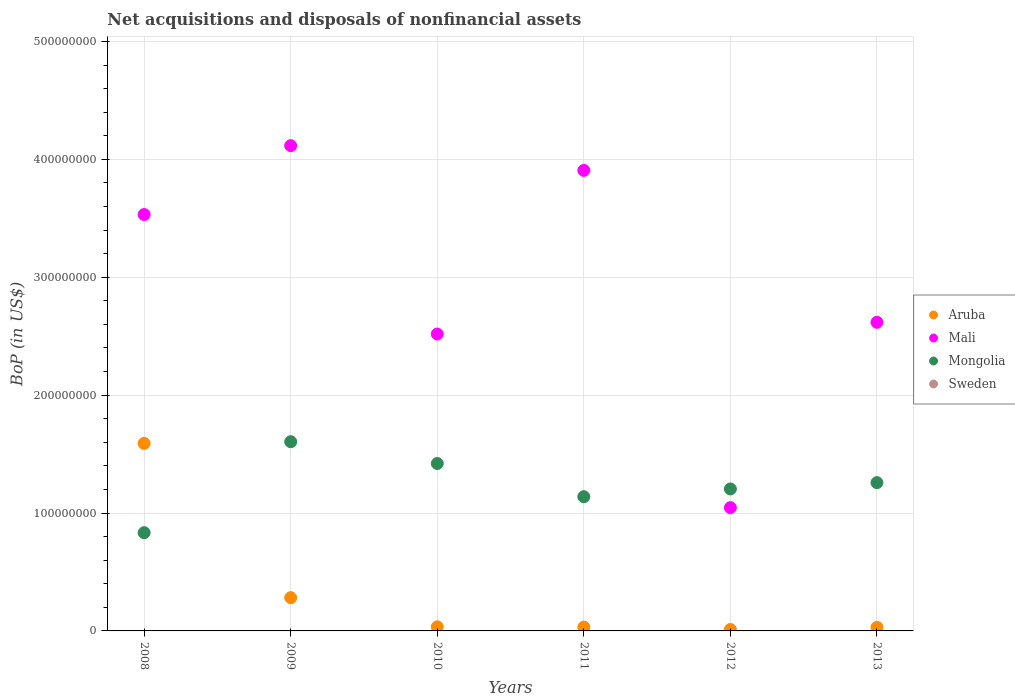Is the number of dotlines equal to the number of legend labels?
Offer a terse response. No. What is the Balance of Payments in Mongolia in 2011?
Provide a succinct answer. 1.14e+08. Across all years, what is the maximum Balance of Payments in Mali?
Your answer should be very brief. 4.12e+08. Across all years, what is the minimum Balance of Payments in Sweden?
Keep it short and to the point. 0. What is the total Balance of Payments in Mongolia in the graph?
Provide a short and direct response. 7.46e+08. What is the difference between the Balance of Payments in Mali in 2009 and that in 2010?
Offer a terse response. 1.60e+08. What is the difference between the Balance of Payments in Mongolia in 2013 and the Balance of Payments in Sweden in 2012?
Provide a short and direct response. 1.26e+08. What is the average Balance of Payments in Mongolia per year?
Give a very brief answer. 1.24e+08. In the year 2012, what is the difference between the Balance of Payments in Mongolia and Balance of Payments in Mali?
Offer a very short reply. 1.59e+07. What is the ratio of the Balance of Payments in Mongolia in 2008 to that in 2013?
Your answer should be very brief. 0.66. Is the Balance of Payments in Mongolia in 2009 less than that in 2012?
Your response must be concise. No. Is the difference between the Balance of Payments in Mongolia in 2010 and 2012 greater than the difference between the Balance of Payments in Mali in 2010 and 2012?
Keep it short and to the point. No. What is the difference between the highest and the second highest Balance of Payments in Mongolia?
Your response must be concise. 1.85e+07. What is the difference between the highest and the lowest Balance of Payments in Mongolia?
Your answer should be very brief. 7.72e+07. In how many years, is the Balance of Payments in Mongolia greater than the average Balance of Payments in Mongolia taken over all years?
Your answer should be compact. 3. Is the Balance of Payments in Mali strictly less than the Balance of Payments in Mongolia over the years?
Keep it short and to the point. No. What is the difference between two consecutive major ticks on the Y-axis?
Keep it short and to the point. 1.00e+08. Does the graph contain any zero values?
Offer a very short reply. Yes. Where does the legend appear in the graph?
Your answer should be compact. Center right. What is the title of the graph?
Give a very brief answer. Net acquisitions and disposals of nonfinancial assets. What is the label or title of the Y-axis?
Your answer should be compact. BoP (in US$). What is the BoP (in US$) of Aruba in 2008?
Provide a short and direct response. 1.59e+08. What is the BoP (in US$) of Mali in 2008?
Ensure brevity in your answer.  3.53e+08. What is the BoP (in US$) in Mongolia in 2008?
Your response must be concise. 8.33e+07. What is the BoP (in US$) in Sweden in 2008?
Make the answer very short. 0. What is the BoP (in US$) in Aruba in 2009?
Offer a terse response. 2.82e+07. What is the BoP (in US$) of Mali in 2009?
Your answer should be compact. 4.12e+08. What is the BoP (in US$) of Mongolia in 2009?
Keep it short and to the point. 1.60e+08. What is the BoP (in US$) of Aruba in 2010?
Give a very brief answer. 3.52e+06. What is the BoP (in US$) of Mali in 2010?
Your response must be concise. 2.52e+08. What is the BoP (in US$) in Mongolia in 2010?
Make the answer very short. 1.42e+08. What is the BoP (in US$) of Sweden in 2010?
Your answer should be very brief. 0. What is the BoP (in US$) of Aruba in 2011?
Offer a very short reply. 3.24e+06. What is the BoP (in US$) in Mali in 2011?
Make the answer very short. 3.91e+08. What is the BoP (in US$) in Mongolia in 2011?
Provide a short and direct response. 1.14e+08. What is the BoP (in US$) in Aruba in 2012?
Your answer should be very brief. 1.23e+06. What is the BoP (in US$) of Mali in 2012?
Offer a very short reply. 1.05e+08. What is the BoP (in US$) in Mongolia in 2012?
Offer a terse response. 1.20e+08. What is the BoP (in US$) of Sweden in 2012?
Offer a terse response. 0. What is the BoP (in US$) in Aruba in 2013?
Your response must be concise. 3.02e+06. What is the BoP (in US$) of Mali in 2013?
Ensure brevity in your answer.  2.62e+08. What is the BoP (in US$) in Mongolia in 2013?
Keep it short and to the point. 1.26e+08. Across all years, what is the maximum BoP (in US$) of Aruba?
Your answer should be compact. 1.59e+08. Across all years, what is the maximum BoP (in US$) of Mali?
Your answer should be compact. 4.12e+08. Across all years, what is the maximum BoP (in US$) of Mongolia?
Offer a terse response. 1.60e+08. Across all years, what is the minimum BoP (in US$) in Aruba?
Give a very brief answer. 1.23e+06. Across all years, what is the minimum BoP (in US$) of Mali?
Your answer should be very brief. 1.05e+08. Across all years, what is the minimum BoP (in US$) in Mongolia?
Provide a short and direct response. 8.33e+07. What is the total BoP (in US$) in Aruba in the graph?
Your response must be concise. 1.98e+08. What is the total BoP (in US$) of Mali in the graph?
Your answer should be very brief. 1.77e+09. What is the total BoP (in US$) in Mongolia in the graph?
Offer a very short reply. 7.46e+08. What is the difference between the BoP (in US$) in Aruba in 2008 and that in 2009?
Keep it short and to the point. 1.31e+08. What is the difference between the BoP (in US$) of Mali in 2008 and that in 2009?
Your answer should be very brief. -5.84e+07. What is the difference between the BoP (in US$) in Mongolia in 2008 and that in 2009?
Provide a succinct answer. -7.72e+07. What is the difference between the BoP (in US$) of Aruba in 2008 and that in 2010?
Offer a very short reply. 1.56e+08. What is the difference between the BoP (in US$) in Mali in 2008 and that in 2010?
Your answer should be compact. 1.01e+08. What is the difference between the BoP (in US$) of Mongolia in 2008 and that in 2010?
Provide a short and direct response. -5.87e+07. What is the difference between the BoP (in US$) in Aruba in 2008 and that in 2011?
Keep it short and to the point. 1.56e+08. What is the difference between the BoP (in US$) of Mali in 2008 and that in 2011?
Offer a terse response. -3.74e+07. What is the difference between the BoP (in US$) in Mongolia in 2008 and that in 2011?
Provide a short and direct response. -3.05e+07. What is the difference between the BoP (in US$) in Aruba in 2008 and that in 2012?
Provide a succinct answer. 1.58e+08. What is the difference between the BoP (in US$) in Mali in 2008 and that in 2012?
Provide a short and direct response. 2.49e+08. What is the difference between the BoP (in US$) in Mongolia in 2008 and that in 2012?
Make the answer very short. -3.71e+07. What is the difference between the BoP (in US$) of Aruba in 2008 and that in 2013?
Your response must be concise. 1.56e+08. What is the difference between the BoP (in US$) of Mali in 2008 and that in 2013?
Provide a succinct answer. 9.14e+07. What is the difference between the BoP (in US$) of Mongolia in 2008 and that in 2013?
Ensure brevity in your answer.  -4.25e+07. What is the difference between the BoP (in US$) of Aruba in 2009 and that in 2010?
Provide a succinct answer. 2.47e+07. What is the difference between the BoP (in US$) in Mali in 2009 and that in 2010?
Keep it short and to the point. 1.60e+08. What is the difference between the BoP (in US$) of Mongolia in 2009 and that in 2010?
Provide a succinct answer. 1.85e+07. What is the difference between the BoP (in US$) in Aruba in 2009 and that in 2011?
Your answer should be very brief. 2.50e+07. What is the difference between the BoP (in US$) in Mali in 2009 and that in 2011?
Offer a terse response. 2.10e+07. What is the difference between the BoP (in US$) of Mongolia in 2009 and that in 2011?
Offer a terse response. 4.66e+07. What is the difference between the BoP (in US$) in Aruba in 2009 and that in 2012?
Keep it short and to the point. 2.70e+07. What is the difference between the BoP (in US$) of Mali in 2009 and that in 2012?
Offer a terse response. 3.07e+08. What is the difference between the BoP (in US$) in Mongolia in 2009 and that in 2012?
Your answer should be compact. 4.01e+07. What is the difference between the BoP (in US$) in Aruba in 2009 and that in 2013?
Your answer should be very brief. 2.52e+07. What is the difference between the BoP (in US$) of Mali in 2009 and that in 2013?
Make the answer very short. 1.50e+08. What is the difference between the BoP (in US$) of Mongolia in 2009 and that in 2013?
Offer a very short reply. 3.47e+07. What is the difference between the BoP (in US$) in Aruba in 2010 and that in 2011?
Your answer should be compact. 2.79e+05. What is the difference between the BoP (in US$) in Mali in 2010 and that in 2011?
Ensure brevity in your answer.  -1.39e+08. What is the difference between the BoP (in US$) in Mongolia in 2010 and that in 2011?
Your answer should be compact. 2.81e+07. What is the difference between the BoP (in US$) of Aruba in 2010 and that in 2012?
Offer a terse response. 2.29e+06. What is the difference between the BoP (in US$) in Mali in 2010 and that in 2012?
Offer a terse response. 1.47e+08. What is the difference between the BoP (in US$) in Mongolia in 2010 and that in 2012?
Provide a succinct answer. 2.16e+07. What is the difference between the BoP (in US$) in Aruba in 2010 and that in 2013?
Provide a succinct answer. 5.03e+05. What is the difference between the BoP (in US$) in Mali in 2010 and that in 2013?
Provide a short and direct response. -9.95e+06. What is the difference between the BoP (in US$) in Mongolia in 2010 and that in 2013?
Make the answer very short. 1.62e+07. What is the difference between the BoP (in US$) of Aruba in 2011 and that in 2012?
Provide a succinct answer. 2.01e+06. What is the difference between the BoP (in US$) in Mali in 2011 and that in 2012?
Provide a short and direct response. 2.86e+08. What is the difference between the BoP (in US$) in Mongolia in 2011 and that in 2012?
Offer a terse response. -6.56e+06. What is the difference between the BoP (in US$) in Aruba in 2011 and that in 2013?
Your response must be concise. 2.23e+05. What is the difference between the BoP (in US$) in Mali in 2011 and that in 2013?
Keep it short and to the point. 1.29e+08. What is the difference between the BoP (in US$) in Mongolia in 2011 and that in 2013?
Provide a short and direct response. -1.19e+07. What is the difference between the BoP (in US$) of Aruba in 2012 and that in 2013?
Your answer should be very brief. -1.79e+06. What is the difference between the BoP (in US$) of Mali in 2012 and that in 2013?
Make the answer very short. -1.57e+08. What is the difference between the BoP (in US$) of Mongolia in 2012 and that in 2013?
Keep it short and to the point. -5.36e+06. What is the difference between the BoP (in US$) of Aruba in 2008 and the BoP (in US$) of Mali in 2009?
Your response must be concise. -2.53e+08. What is the difference between the BoP (in US$) in Aruba in 2008 and the BoP (in US$) in Mongolia in 2009?
Make the answer very short. -1.45e+06. What is the difference between the BoP (in US$) of Mali in 2008 and the BoP (in US$) of Mongolia in 2009?
Your answer should be very brief. 1.93e+08. What is the difference between the BoP (in US$) in Aruba in 2008 and the BoP (in US$) in Mali in 2010?
Your response must be concise. -9.28e+07. What is the difference between the BoP (in US$) in Aruba in 2008 and the BoP (in US$) in Mongolia in 2010?
Offer a terse response. 1.70e+07. What is the difference between the BoP (in US$) in Mali in 2008 and the BoP (in US$) in Mongolia in 2010?
Make the answer very short. 2.11e+08. What is the difference between the BoP (in US$) of Aruba in 2008 and the BoP (in US$) of Mali in 2011?
Your answer should be very brief. -2.32e+08. What is the difference between the BoP (in US$) of Aruba in 2008 and the BoP (in US$) of Mongolia in 2011?
Offer a terse response. 4.52e+07. What is the difference between the BoP (in US$) in Mali in 2008 and the BoP (in US$) in Mongolia in 2011?
Keep it short and to the point. 2.39e+08. What is the difference between the BoP (in US$) of Aruba in 2008 and the BoP (in US$) of Mali in 2012?
Keep it short and to the point. 5.45e+07. What is the difference between the BoP (in US$) in Aruba in 2008 and the BoP (in US$) in Mongolia in 2012?
Ensure brevity in your answer.  3.86e+07. What is the difference between the BoP (in US$) in Mali in 2008 and the BoP (in US$) in Mongolia in 2012?
Your answer should be compact. 2.33e+08. What is the difference between the BoP (in US$) in Aruba in 2008 and the BoP (in US$) in Mali in 2013?
Your answer should be very brief. -1.03e+08. What is the difference between the BoP (in US$) in Aruba in 2008 and the BoP (in US$) in Mongolia in 2013?
Offer a terse response. 3.33e+07. What is the difference between the BoP (in US$) of Mali in 2008 and the BoP (in US$) of Mongolia in 2013?
Make the answer very short. 2.27e+08. What is the difference between the BoP (in US$) of Aruba in 2009 and the BoP (in US$) of Mali in 2010?
Provide a short and direct response. -2.24e+08. What is the difference between the BoP (in US$) in Aruba in 2009 and the BoP (in US$) in Mongolia in 2010?
Make the answer very short. -1.14e+08. What is the difference between the BoP (in US$) in Mali in 2009 and the BoP (in US$) in Mongolia in 2010?
Give a very brief answer. 2.70e+08. What is the difference between the BoP (in US$) in Aruba in 2009 and the BoP (in US$) in Mali in 2011?
Your response must be concise. -3.62e+08. What is the difference between the BoP (in US$) of Aruba in 2009 and the BoP (in US$) of Mongolia in 2011?
Offer a very short reply. -8.57e+07. What is the difference between the BoP (in US$) of Mali in 2009 and the BoP (in US$) of Mongolia in 2011?
Your response must be concise. 2.98e+08. What is the difference between the BoP (in US$) of Aruba in 2009 and the BoP (in US$) of Mali in 2012?
Make the answer very short. -7.64e+07. What is the difference between the BoP (in US$) in Aruba in 2009 and the BoP (in US$) in Mongolia in 2012?
Your answer should be compact. -9.22e+07. What is the difference between the BoP (in US$) in Mali in 2009 and the BoP (in US$) in Mongolia in 2012?
Offer a very short reply. 2.91e+08. What is the difference between the BoP (in US$) of Aruba in 2009 and the BoP (in US$) of Mali in 2013?
Make the answer very short. -2.34e+08. What is the difference between the BoP (in US$) in Aruba in 2009 and the BoP (in US$) in Mongolia in 2013?
Ensure brevity in your answer.  -9.76e+07. What is the difference between the BoP (in US$) in Mali in 2009 and the BoP (in US$) in Mongolia in 2013?
Your response must be concise. 2.86e+08. What is the difference between the BoP (in US$) of Aruba in 2010 and the BoP (in US$) of Mali in 2011?
Your response must be concise. -3.87e+08. What is the difference between the BoP (in US$) in Aruba in 2010 and the BoP (in US$) in Mongolia in 2011?
Your answer should be compact. -1.10e+08. What is the difference between the BoP (in US$) of Mali in 2010 and the BoP (in US$) of Mongolia in 2011?
Give a very brief answer. 1.38e+08. What is the difference between the BoP (in US$) of Aruba in 2010 and the BoP (in US$) of Mali in 2012?
Make the answer very short. -1.01e+08. What is the difference between the BoP (in US$) of Aruba in 2010 and the BoP (in US$) of Mongolia in 2012?
Offer a very short reply. -1.17e+08. What is the difference between the BoP (in US$) of Mali in 2010 and the BoP (in US$) of Mongolia in 2012?
Offer a terse response. 1.31e+08. What is the difference between the BoP (in US$) in Aruba in 2010 and the BoP (in US$) in Mali in 2013?
Provide a short and direct response. -2.58e+08. What is the difference between the BoP (in US$) of Aruba in 2010 and the BoP (in US$) of Mongolia in 2013?
Offer a terse response. -1.22e+08. What is the difference between the BoP (in US$) in Mali in 2010 and the BoP (in US$) in Mongolia in 2013?
Give a very brief answer. 1.26e+08. What is the difference between the BoP (in US$) in Aruba in 2011 and the BoP (in US$) in Mali in 2012?
Offer a very short reply. -1.01e+08. What is the difference between the BoP (in US$) of Aruba in 2011 and the BoP (in US$) of Mongolia in 2012?
Give a very brief answer. -1.17e+08. What is the difference between the BoP (in US$) of Mali in 2011 and the BoP (in US$) of Mongolia in 2012?
Offer a terse response. 2.70e+08. What is the difference between the BoP (in US$) of Aruba in 2011 and the BoP (in US$) of Mali in 2013?
Provide a short and direct response. -2.59e+08. What is the difference between the BoP (in US$) in Aruba in 2011 and the BoP (in US$) in Mongolia in 2013?
Your answer should be compact. -1.23e+08. What is the difference between the BoP (in US$) of Mali in 2011 and the BoP (in US$) of Mongolia in 2013?
Provide a short and direct response. 2.65e+08. What is the difference between the BoP (in US$) of Aruba in 2012 and the BoP (in US$) of Mali in 2013?
Your answer should be very brief. -2.61e+08. What is the difference between the BoP (in US$) of Aruba in 2012 and the BoP (in US$) of Mongolia in 2013?
Your response must be concise. -1.25e+08. What is the difference between the BoP (in US$) of Mali in 2012 and the BoP (in US$) of Mongolia in 2013?
Your answer should be compact. -2.12e+07. What is the average BoP (in US$) of Aruba per year?
Provide a succinct answer. 3.30e+07. What is the average BoP (in US$) of Mali per year?
Make the answer very short. 2.96e+08. What is the average BoP (in US$) in Mongolia per year?
Offer a terse response. 1.24e+08. In the year 2008, what is the difference between the BoP (in US$) of Aruba and BoP (in US$) of Mali?
Your response must be concise. -1.94e+08. In the year 2008, what is the difference between the BoP (in US$) in Aruba and BoP (in US$) in Mongolia?
Offer a terse response. 7.57e+07. In the year 2008, what is the difference between the BoP (in US$) of Mali and BoP (in US$) of Mongolia?
Make the answer very short. 2.70e+08. In the year 2009, what is the difference between the BoP (in US$) of Aruba and BoP (in US$) of Mali?
Offer a terse response. -3.83e+08. In the year 2009, what is the difference between the BoP (in US$) in Aruba and BoP (in US$) in Mongolia?
Make the answer very short. -1.32e+08. In the year 2009, what is the difference between the BoP (in US$) in Mali and BoP (in US$) in Mongolia?
Keep it short and to the point. 2.51e+08. In the year 2010, what is the difference between the BoP (in US$) of Aruba and BoP (in US$) of Mali?
Offer a terse response. -2.48e+08. In the year 2010, what is the difference between the BoP (in US$) in Aruba and BoP (in US$) in Mongolia?
Give a very brief answer. -1.38e+08. In the year 2010, what is the difference between the BoP (in US$) of Mali and BoP (in US$) of Mongolia?
Your response must be concise. 1.10e+08. In the year 2011, what is the difference between the BoP (in US$) in Aruba and BoP (in US$) in Mali?
Your answer should be compact. -3.87e+08. In the year 2011, what is the difference between the BoP (in US$) in Aruba and BoP (in US$) in Mongolia?
Your answer should be compact. -1.11e+08. In the year 2011, what is the difference between the BoP (in US$) in Mali and BoP (in US$) in Mongolia?
Your response must be concise. 2.77e+08. In the year 2012, what is the difference between the BoP (in US$) of Aruba and BoP (in US$) of Mali?
Ensure brevity in your answer.  -1.03e+08. In the year 2012, what is the difference between the BoP (in US$) in Aruba and BoP (in US$) in Mongolia?
Offer a very short reply. -1.19e+08. In the year 2012, what is the difference between the BoP (in US$) in Mali and BoP (in US$) in Mongolia?
Provide a short and direct response. -1.59e+07. In the year 2013, what is the difference between the BoP (in US$) of Aruba and BoP (in US$) of Mali?
Provide a short and direct response. -2.59e+08. In the year 2013, what is the difference between the BoP (in US$) of Aruba and BoP (in US$) of Mongolia?
Provide a short and direct response. -1.23e+08. In the year 2013, what is the difference between the BoP (in US$) in Mali and BoP (in US$) in Mongolia?
Provide a short and direct response. 1.36e+08. What is the ratio of the BoP (in US$) of Aruba in 2008 to that in 2009?
Provide a succinct answer. 5.64. What is the ratio of the BoP (in US$) in Mali in 2008 to that in 2009?
Offer a terse response. 0.86. What is the ratio of the BoP (in US$) in Mongolia in 2008 to that in 2009?
Offer a very short reply. 0.52. What is the ratio of the BoP (in US$) of Aruba in 2008 to that in 2010?
Offer a terse response. 45.19. What is the ratio of the BoP (in US$) in Mali in 2008 to that in 2010?
Provide a short and direct response. 1.4. What is the ratio of the BoP (in US$) in Mongolia in 2008 to that in 2010?
Make the answer very short. 0.59. What is the ratio of the BoP (in US$) of Aruba in 2008 to that in 2011?
Offer a terse response. 49.09. What is the ratio of the BoP (in US$) of Mali in 2008 to that in 2011?
Your response must be concise. 0.9. What is the ratio of the BoP (in US$) in Mongolia in 2008 to that in 2011?
Give a very brief answer. 0.73. What is the ratio of the BoP (in US$) of Aruba in 2008 to that in 2012?
Provide a succinct answer. 129.41. What is the ratio of the BoP (in US$) in Mali in 2008 to that in 2012?
Keep it short and to the point. 3.38. What is the ratio of the BoP (in US$) of Mongolia in 2008 to that in 2012?
Keep it short and to the point. 0.69. What is the ratio of the BoP (in US$) of Aruba in 2008 to that in 2013?
Your answer should be very brief. 52.72. What is the ratio of the BoP (in US$) of Mali in 2008 to that in 2013?
Your answer should be compact. 1.35. What is the ratio of the BoP (in US$) of Mongolia in 2008 to that in 2013?
Keep it short and to the point. 0.66. What is the ratio of the BoP (in US$) of Aruba in 2009 to that in 2010?
Make the answer very short. 8.02. What is the ratio of the BoP (in US$) in Mali in 2009 to that in 2010?
Offer a terse response. 1.63. What is the ratio of the BoP (in US$) in Mongolia in 2009 to that in 2010?
Offer a very short reply. 1.13. What is the ratio of the BoP (in US$) of Aruba in 2009 to that in 2011?
Your answer should be compact. 8.71. What is the ratio of the BoP (in US$) of Mali in 2009 to that in 2011?
Offer a very short reply. 1.05. What is the ratio of the BoP (in US$) in Mongolia in 2009 to that in 2011?
Your answer should be very brief. 1.41. What is the ratio of the BoP (in US$) in Aruba in 2009 to that in 2012?
Offer a very short reply. 22.95. What is the ratio of the BoP (in US$) of Mali in 2009 to that in 2012?
Ensure brevity in your answer.  3.94. What is the ratio of the BoP (in US$) of Mongolia in 2009 to that in 2012?
Offer a terse response. 1.33. What is the ratio of the BoP (in US$) in Aruba in 2009 to that in 2013?
Provide a short and direct response. 9.35. What is the ratio of the BoP (in US$) of Mali in 2009 to that in 2013?
Provide a succinct answer. 1.57. What is the ratio of the BoP (in US$) in Mongolia in 2009 to that in 2013?
Ensure brevity in your answer.  1.28. What is the ratio of the BoP (in US$) of Aruba in 2010 to that in 2011?
Your answer should be very brief. 1.09. What is the ratio of the BoP (in US$) of Mali in 2010 to that in 2011?
Make the answer very short. 0.64. What is the ratio of the BoP (in US$) in Mongolia in 2010 to that in 2011?
Offer a very short reply. 1.25. What is the ratio of the BoP (in US$) of Aruba in 2010 to that in 2012?
Your response must be concise. 2.86. What is the ratio of the BoP (in US$) in Mali in 2010 to that in 2012?
Offer a very short reply. 2.41. What is the ratio of the BoP (in US$) of Mongolia in 2010 to that in 2012?
Provide a short and direct response. 1.18. What is the ratio of the BoP (in US$) of Mali in 2010 to that in 2013?
Make the answer very short. 0.96. What is the ratio of the BoP (in US$) in Mongolia in 2010 to that in 2013?
Offer a very short reply. 1.13. What is the ratio of the BoP (in US$) of Aruba in 2011 to that in 2012?
Offer a terse response. 2.64. What is the ratio of the BoP (in US$) of Mali in 2011 to that in 2012?
Your answer should be very brief. 3.74. What is the ratio of the BoP (in US$) of Mongolia in 2011 to that in 2012?
Make the answer very short. 0.95. What is the ratio of the BoP (in US$) of Aruba in 2011 to that in 2013?
Give a very brief answer. 1.07. What is the ratio of the BoP (in US$) of Mali in 2011 to that in 2013?
Give a very brief answer. 1.49. What is the ratio of the BoP (in US$) in Mongolia in 2011 to that in 2013?
Give a very brief answer. 0.91. What is the ratio of the BoP (in US$) in Aruba in 2012 to that in 2013?
Provide a succinct answer. 0.41. What is the ratio of the BoP (in US$) of Mali in 2012 to that in 2013?
Offer a terse response. 0.4. What is the ratio of the BoP (in US$) of Mongolia in 2012 to that in 2013?
Your answer should be compact. 0.96. What is the difference between the highest and the second highest BoP (in US$) of Aruba?
Offer a very short reply. 1.31e+08. What is the difference between the highest and the second highest BoP (in US$) of Mali?
Make the answer very short. 2.10e+07. What is the difference between the highest and the second highest BoP (in US$) of Mongolia?
Offer a terse response. 1.85e+07. What is the difference between the highest and the lowest BoP (in US$) of Aruba?
Your answer should be very brief. 1.58e+08. What is the difference between the highest and the lowest BoP (in US$) of Mali?
Provide a short and direct response. 3.07e+08. What is the difference between the highest and the lowest BoP (in US$) in Mongolia?
Your answer should be compact. 7.72e+07. 